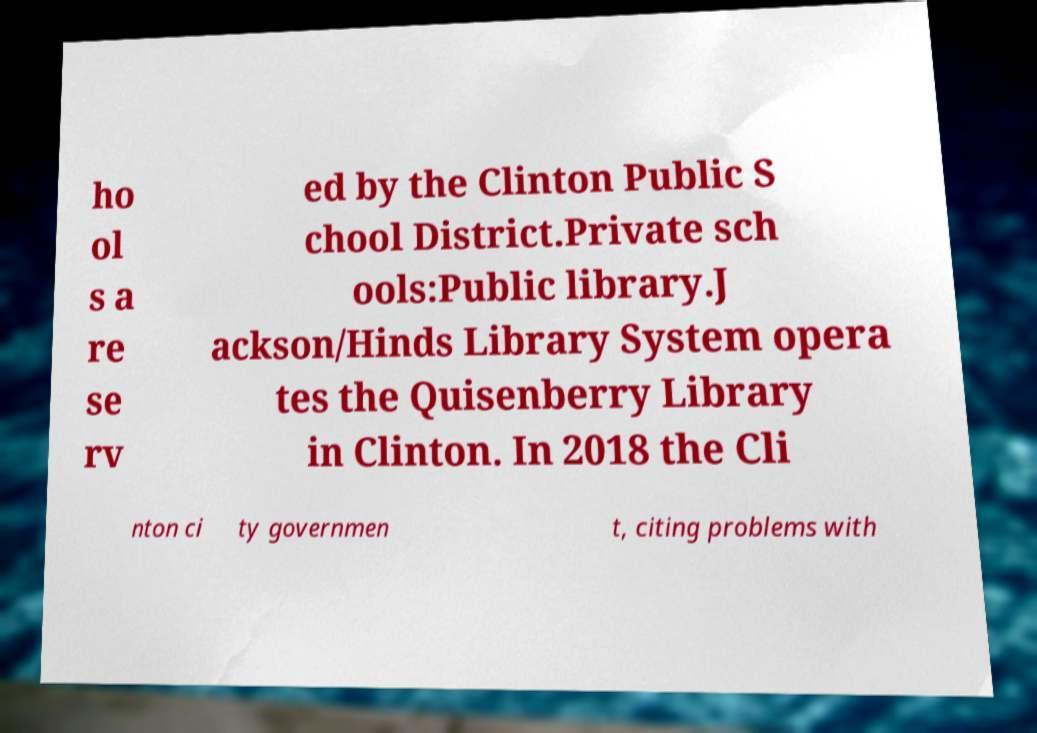Please identify and transcribe the text found in this image. ho ol s a re se rv ed by the Clinton Public S chool District.Private sch ools:Public library.J ackson/Hinds Library System opera tes the Quisenberry Library in Clinton. In 2018 the Cli nton ci ty governmen t, citing problems with 